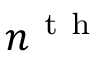Convert formula to latex. <formula><loc_0><loc_0><loc_500><loc_500>n ^ { t h }</formula> 